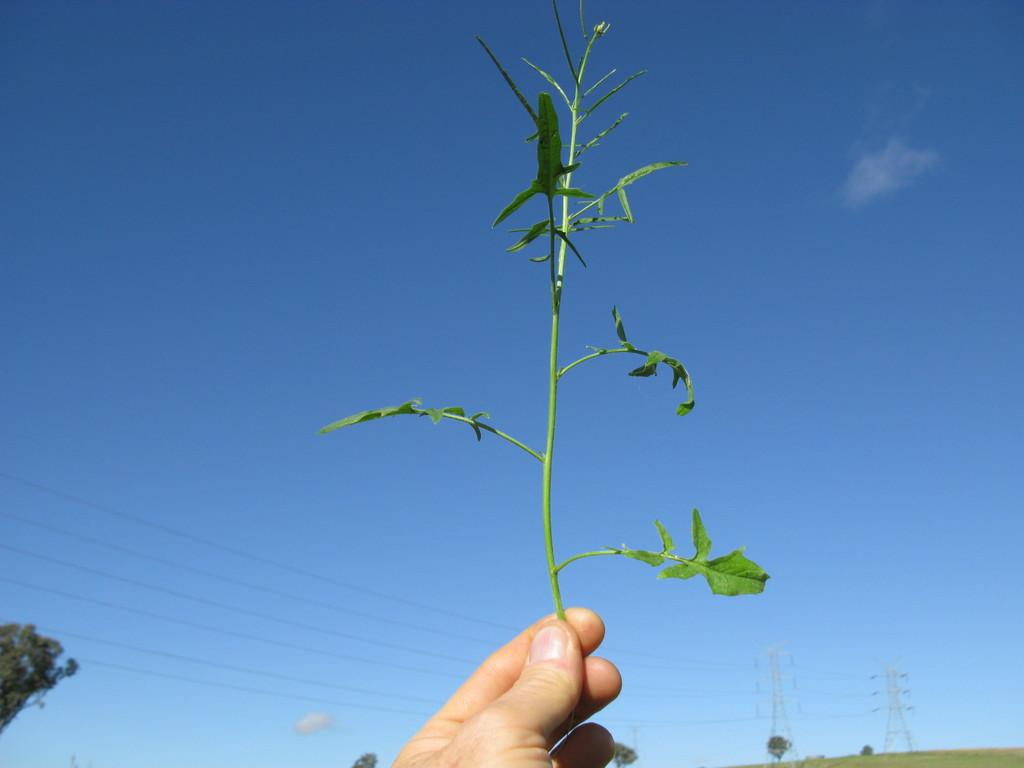What part of a person's body is visible in the image? There is a person's hand visible in the image. What is the person holding in their hand? The person is holding a stem in their hand. What can be seen in the background of the image? There are trees and electric towers with cables in the background of the image. What is visible in the sky in the image? The sky is visible in the background of the image. What type of vein is visible in the image? There is no vein visible in the image; it features a person's hand holding a stem. What territory is being claimed by the person in the image? There is no indication of territory being claimed in the image; it simply shows a person holding a stem. 